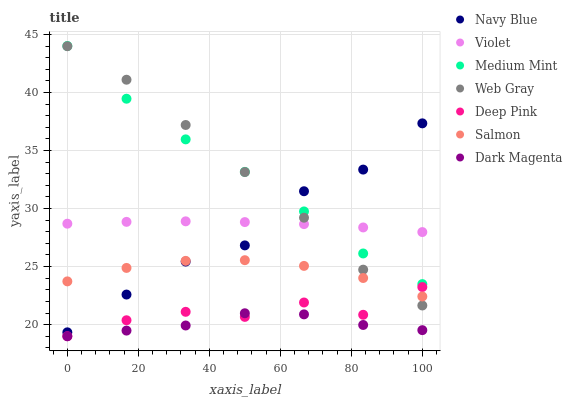Does Dark Magenta have the minimum area under the curve?
Answer yes or no. Yes. Does Medium Mint have the maximum area under the curve?
Answer yes or no. Yes. Does Web Gray have the minimum area under the curve?
Answer yes or no. No. Does Web Gray have the maximum area under the curve?
Answer yes or no. No. Is Violet the smoothest?
Answer yes or no. Yes. Is Navy Blue the roughest?
Answer yes or no. Yes. Is Web Gray the smoothest?
Answer yes or no. No. Is Web Gray the roughest?
Answer yes or no. No. Does Dark Magenta have the lowest value?
Answer yes or no. Yes. Does Web Gray have the lowest value?
Answer yes or no. No. Does Medium Mint have the highest value?
Answer yes or no. Yes. Does Web Gray have the highest value?
Answer yes or no. No. Is Deep Pink less than Medium Mint?
Answer yes or no. Yes. Is Medium Mint greater than Dark Magenta?
Answer yes or no. Yes. Does Violet intersect Navy Blue?
Answer yes or no. Yes. Is Violet less than Navy Blue?
Answer yes or no. No. Is Violet greater than Navy Blue?
Answer yes or no. No. Does Deep Pink intersect Medium Mint?
Answer yes or no. No. 